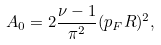<formula> <loc_0><loc_0><loc_500><loc_500>A _ { 0 } = 2 \frac { \nu - 1 } { \pi ^ { 2 } } ( p _ { F } R ) ^ { 2 } ,</formula> 